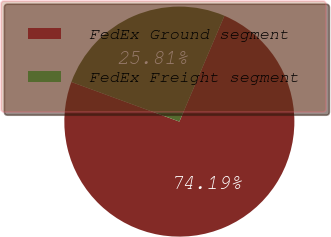Convert chart to OTSL. <chart><loc_0><loc_0><loc_500><loc_500><pie_chart><fcel>FedEx Ground segment<fcel>FedEx Freight segment<nl><fcel>74.19%<fcel>25.81%<nl></chart> 